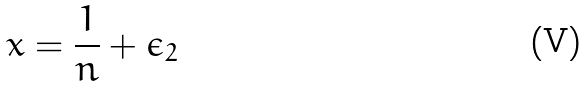Convert formula to latex. <formula><loc_0><loc_0><loc_500><loc_500>x = \frac { 1 } { n } + \epsilon _ { 2 }</formula> 